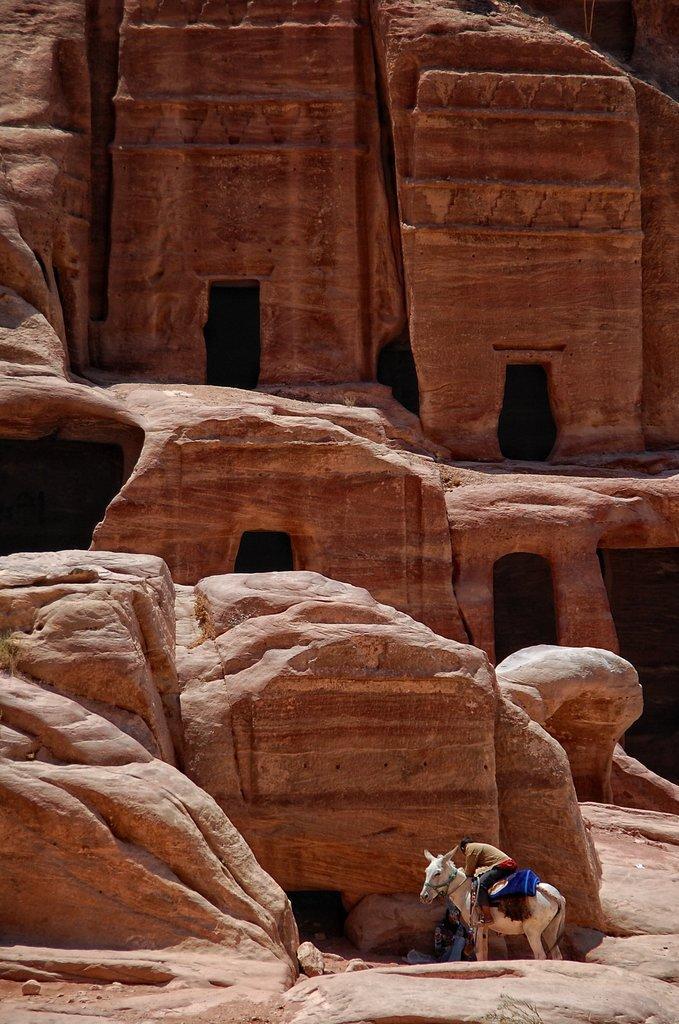Could you give a brief overview of what you see in this image? In this image we can see rocks, there a person is sitting on a white horse. 